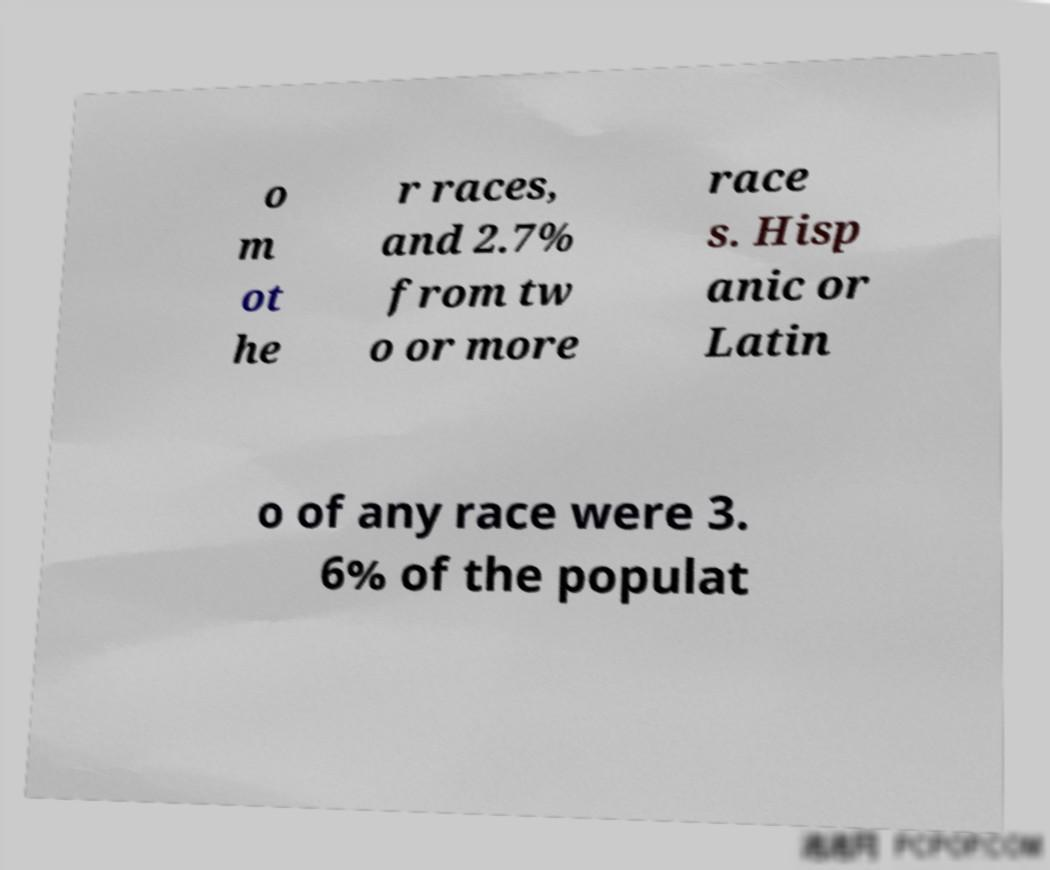Can you read and provide the text displayed in the image?This photo seems to have some interesting text. Can you extract and type it out for me? o m ot he r races, and 2.7% from tw o or more race s. Hisp anic or Latin o of any race were 3. 6% of the populat 